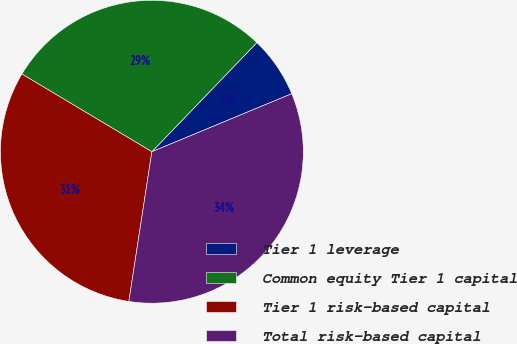Convert chart. <chart><loc_0><loc_0><loc_500><loc_500><pie_chart><fcel>Tier 1 leverage<fcel>Common equity Tier 1 capital<fcel>Tier 1 risk-based capital<fcel>Total risk-based capital<nl><fcel>6.55%<fcel>28.61%<fcel>31.15%<fcel>33.69%<nl></chart> 